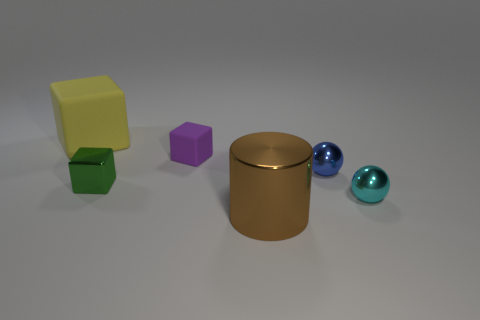Add 1 tiny objects. How many objects exist? 7 Subtract 1 cubes. How many cubes are left? 2 Subtract all rubber cubes. How many cubes are left? 1 Subtract all purple cubes. How many cubes are left? 2 Subtract all cylinders. How many objects are left? 5 Subtract 0 purple cylinders. How many objects are left? 6 Subtract all blue cylinders. Subtract all red balls. How many cylinders are left? 1 Subtract all brown cubes. How many yellow cylinders are left? 0 Subtract all blue spheres. Subtract all green blocks. How many objects are left? 4 Add 6 purple matte blocks. How many purple matte blocks are left? 7 